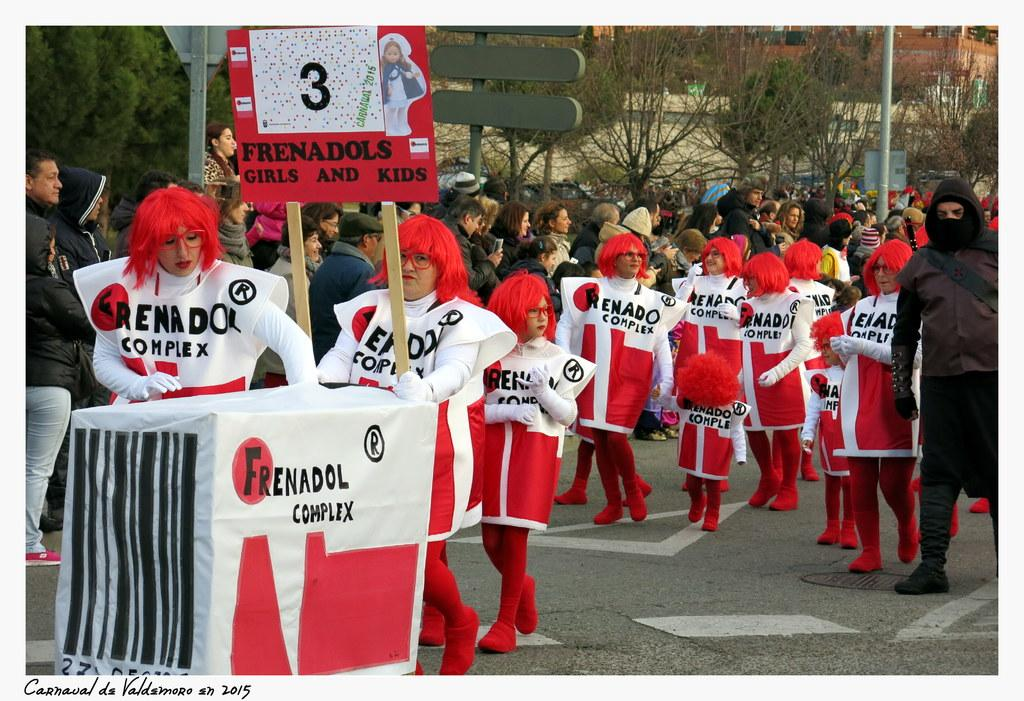<image>
Present a compact description of the photo's key features. People walking in a parade wearing shirts that say "Frenadol Complex". 